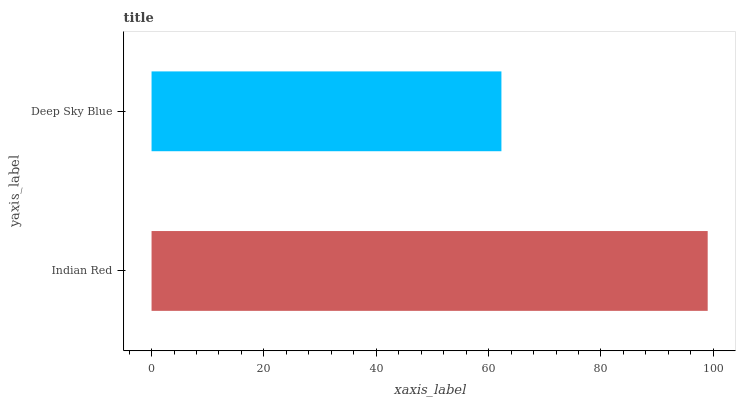Is Deep Sky Blue the minimum?
Answer yes or no. Yes. Is Indian Red the maximum?
Answer yes or no. Yes. Is Deep Sky Blue the maximum?
Answer yes or no. No. Is Indian Red greater than Deep Sky Blue?
Answer yes or no. Yes. Is Deep Sky Blue less than Indian Red?
Answer yes or no. Yes. Is Deep Sky Blue greater than Indian Red?
Answer yes or no. No. Is Indian Red less than Deep Sky Blue?
Answer yes or no. No. Is Indian Red the high median?
Answer yes or no. Yes. Is Deep Sky Blue the low median?
Answer yes or no. Yes. Is Deep Sky Blue the high median?
Answer yes or no. No. Is Indian Red the low median?
Answer yes or no. No. 